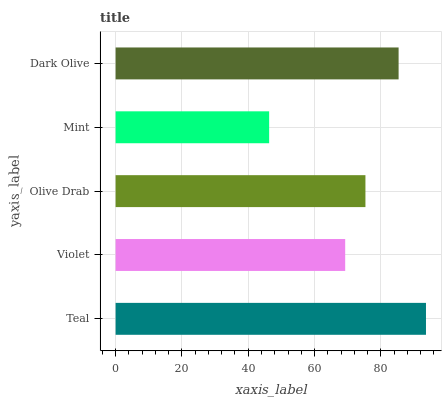Is Mint the minimum?
Answer yes or no. Yes. Is Teal the maximum?
Answer yes or no. Yes. Is Violet the minimum?
Answer yes or no. No. Is Violet the maximum?
Answer yes or no. No. Is Teal greater than Violet?
Answer yes or no. Yes. Is Violet less than Teal?
Answer yes or no. Yes. Is Violet greater than Teal?
Answer yes or no. No. Is Teal less than Violet?
Answer yes or no. No. Is Olive Drab the high median?
Answer yes or no. Yes. Is Olive Drab the low median?
Answer yes or no. Yes. Is Teal the high median?
Answer yes or no. No. Is Dark Olive the low median?
Answer yes or no. No. 